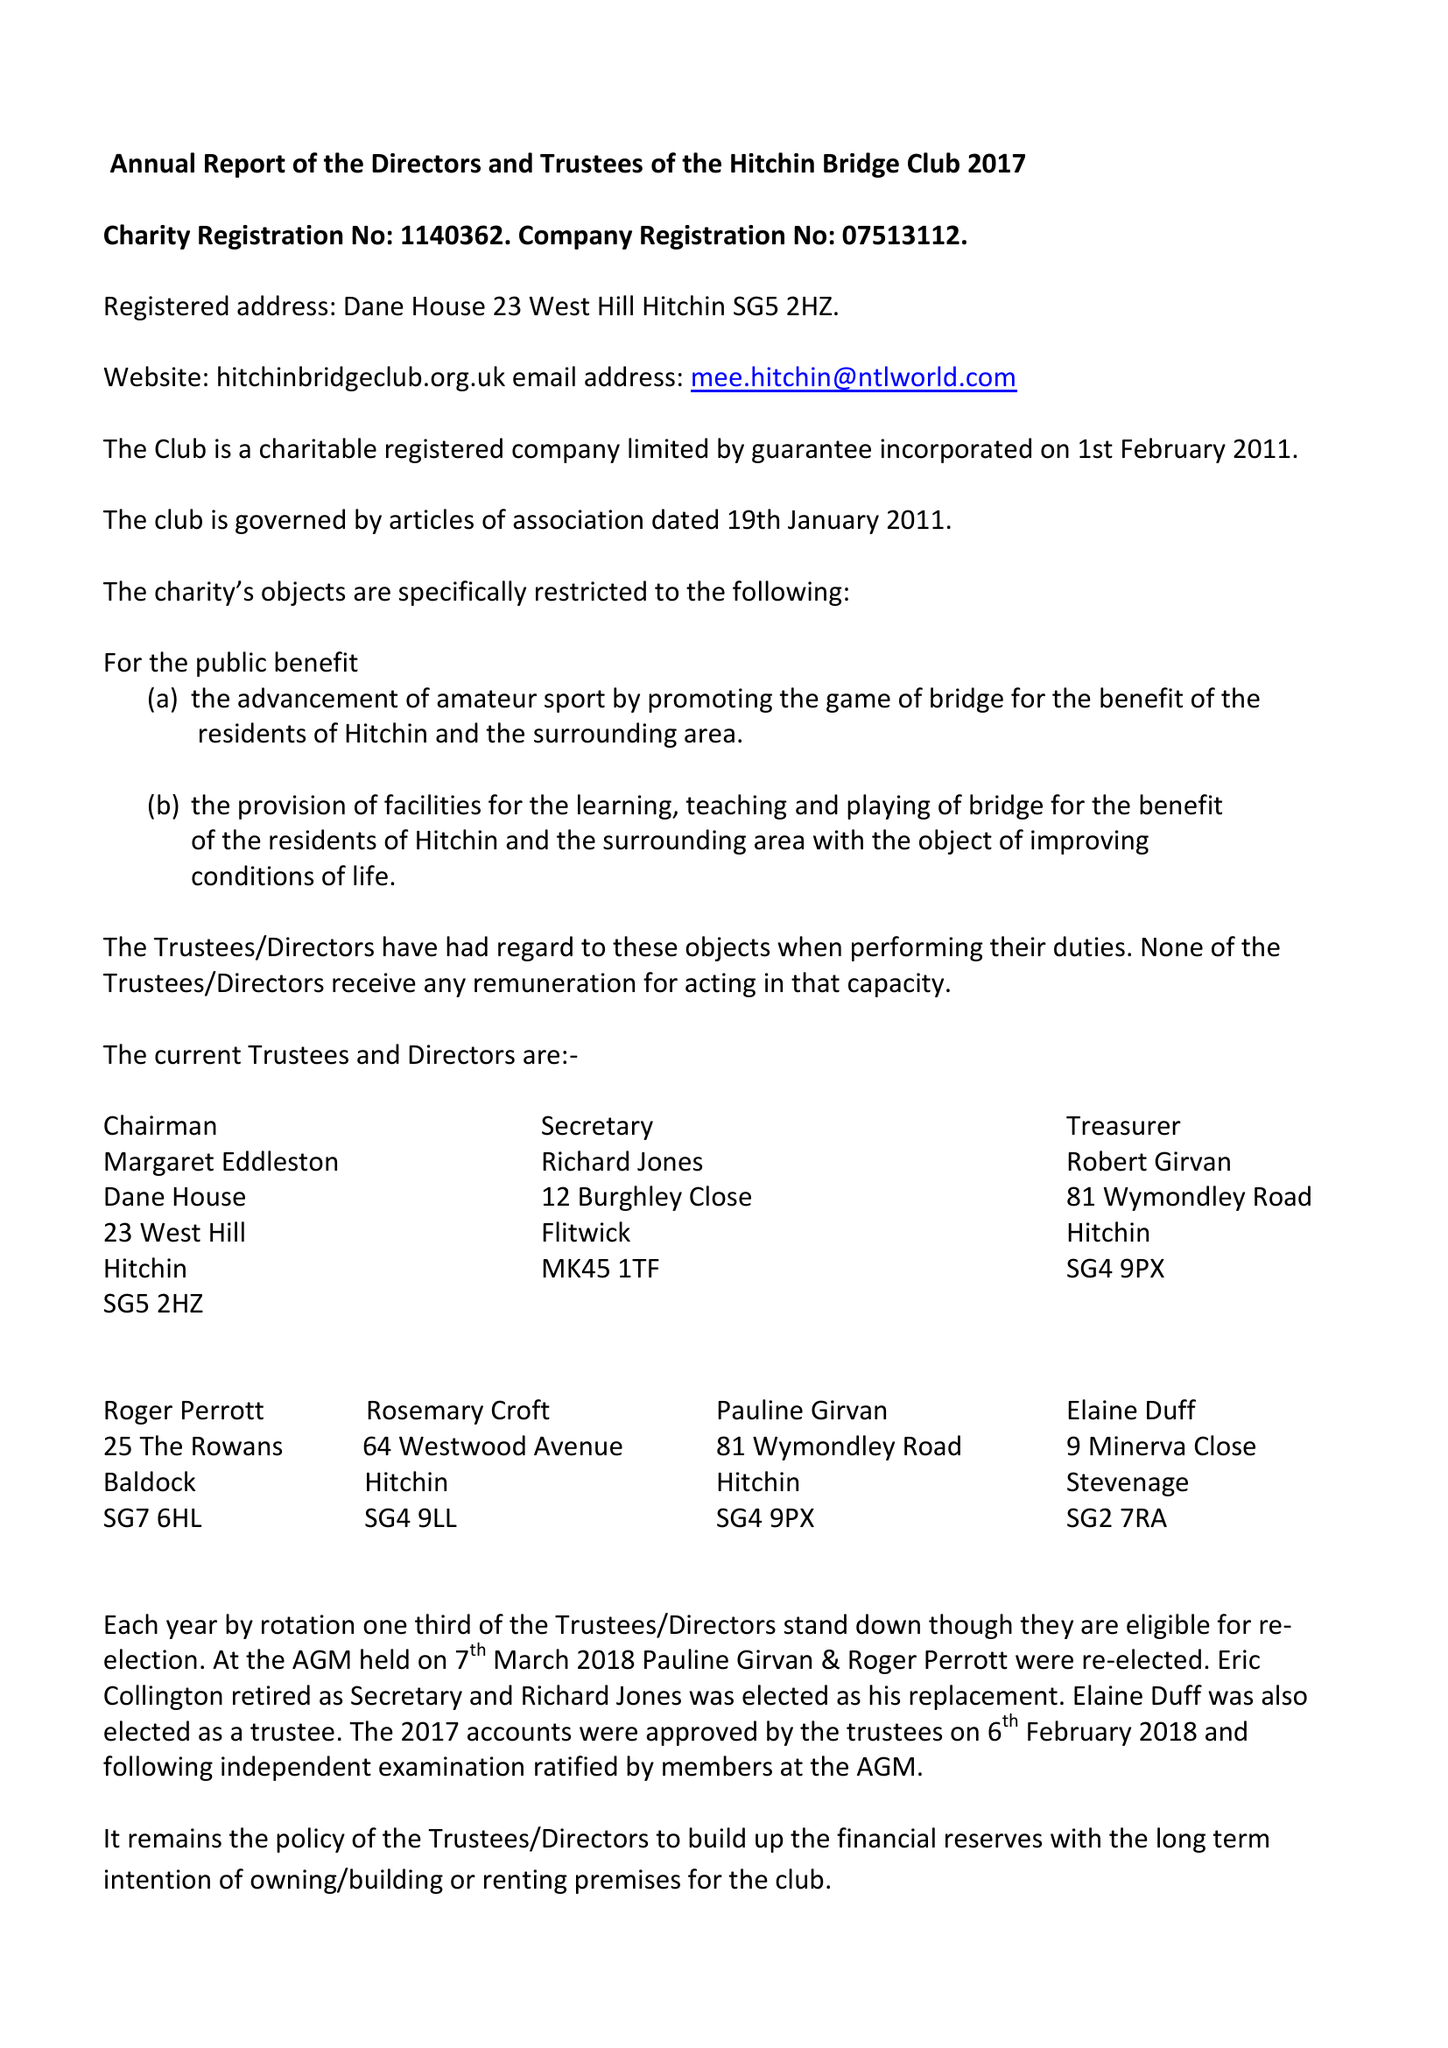What is the value for the address__street_line?
Answer the question using a single word or phrase. None 